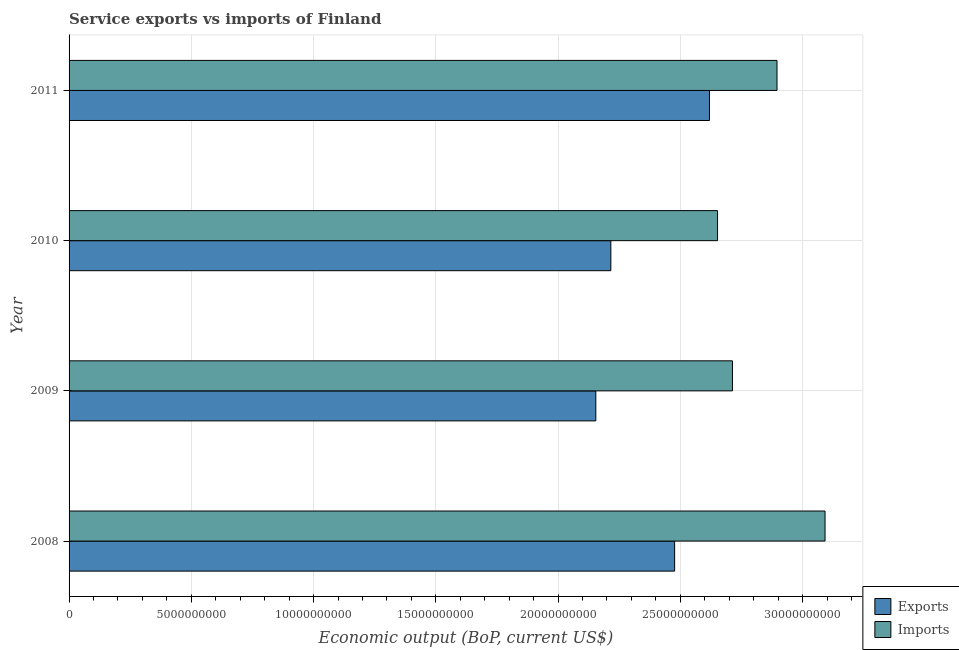How many groups of bars are there?
Offer a very short reply. 4. Are the number of bars on each tick of the Y-axis equal?
Give a very brief answer. Yes. How many bars are there on the 2nd tick from the top?
Make the answer very short. 2. How many bars are there on the 1st tick from the bottom?
Ensure brevity in your answer.  2. What is the amount of service exports in 2008?
Offer a terse response. 2.48e+1. Across all years, what is the maximum amount of service exports?
Keep it short and to the point. 2.62e+1. Across all years, what is the minimum amount of service imports?
Ensure brevity in your answer.  2.65e+1. In which year was the amount of service imports minimum?
Give a very brief answer. 2010. What is the total amount of service exports in the graph?
Offer a terse response. 9.47e+1. What is the difference between the amount of service exports in 2008 and that in 2009?
Give a very brief answer. 3.22e+09. What is the difference between the amount of service exports in 2009 and the amount of service imports in 2010?
Give a very brief answer. -4.98e+09. What is the average amount of service exports per year?
Your answer should be compact. 2.37e+1. In the year 2010, what is the difference between the amount of service imports and amount of service exports?
Provide a succinct answer. 4.36e+09. In how many years, is the amount of service exports greater than 11000000000 US$?
Offer a terse response. 4. Is the amount of service imports in 2008 less than that in 2009?
Your response must be concise. No. Is the difference between the amount of service exports in 2010 and 2011 greater than the difference between the amount of service imports in 2010 and 2011?
Your answer should be very brief. No. What is the difference between the highest and the second highest amount of service exports?
Your answer should be very brief. 1.43e+09. What is the difference between the highest and the lowest amount of service imports?
Give a very brief answer. 4.40e+09. What does the 2nd bar from the top in 2010 represents?
Offer a very short reply. Exports. What does the 1st bar from the bottom in 2008 represents?
Offer a terse response. Exports. How many bars are there?
Keep it short and to the point. 8. How many years are there in the graph?
Your response must be concise. 4. Does the graph contain grids?
Your answer should be very brief. Yes. How many legend labels are there?
Offer a terse response. 2. How are the legend labels stacked?
Keep it short and to the point. Vertical. What is the title of the graph?
Keep it short and to the point. Service exports vs imports of Finland. What is the label or title of the X-axis?
Your answer should be compact. Economic output (BoP, current US$). What is the label or title of the Y-axis?
Offer a very short reply. Year. What is the Economic output (BoP, current US$) in Exports in 2008?
Make the answer very short. 2.48e+1. What is the Economic output (BoP, current US$) in Imports in 2008?
Offer a very short reply. 3.09e+1. What is the Economic output (BoP, current US$) of Exports in 2009?
Offer a terse response. 2.15e+1. What is the Economic output (BoP, current US$) of Imports in 2009?
Provide a succinct answer. 2.71e+1. What is the Economic output (BoP, current US$) of Exports in 2010?
Offer a terse response. 2.22e+1. What is the Economic output (BoP, current US$) of Imports in 2010?
Provide a succinct answer. 2.65e+1. What is the Economic output (BoP, current US$) in Exports in 2011?
Give a very brief answer. 2.62e+1. What is the Economic output (BoP, current US$) in Imports in 2011?
Provide a succinct answer. 2.90e+1. Across all years, what is the maximum Economic output (BoP, current US$) of Exports?
Offer a very short reply. 2.62e+1. Across all years, what is the maximum Economic output (BoP, current US$) in Imports?
Your answer should be compact. 3.09e+1. Across all years, what is the minimum Economic output (BoP, current US$) in Exports?
Make the answer very short. 2.15e+1. Across all years, what is the minimum Economic output (BoP, current US$) in Imports?
Your answer should be compact. 2.65e+1. What is the total Economic output (BoP, current US$) in Exports in the graph?
Your response must be concise. 9.47e+1. What is the total Economic output (BoP, current US$) in Imports in the graph?
Make the answer very short. 1.14e+11. What is the difference between the Economic output (BoP, current US$) in Exports in 2008 and that in 2009?
Provide a succinct answer. 3.22e+09. What is the difference between the Economic output (BoP, current US$) in Imports in 2008 and that in 2009?
Make the answer very short. 3.79e+09. What is the difference between the Economic output (BoP, current US$) in Exports in 2008 and that in 2010?
Your response must be concise. 2.61e+09. What is the difference between the Economic output (BoP, current US$) in Imports in 2008 and that in 2010?
Make the answer very short. 4.40e+09. What is the difference between the Economic output (BoP, current US$) of Exports in 2008 and that in 2011?
Give a very brief answer. -1.43e+09. What is the difference between the Economic output (BoP, current US$) of Imports in 2008 and that in 2011?
Give a very brief answer. 1.96e+09. What is the difference between the Economic output (BoP, current US$) in Exports in 2009 and that in 2010?
Ensure brevity in your answer.  -6.15e+08. What is the difference between the Economic output (BoP, current US$) of Imports in 2009 and that in 2010?
Your answer should be very brief. 6.09e+08. What is the difference between the Economic output (BoP, current US$) of Exports in 2009 and that in 2011?
Your answer should be compact. -4.65e+09. What is the difference between the Economic output (BoP, current US$) of Imports in 2009 and that in 2011?
Make the answer very short. -1.82e+09. What is the difference between the Economic output (BoP, current US$) of Exports in 2010 and that in 2011?
Provide a short and direct response. -4.03e+09. What is the difference between the Economic output (BoP, current US$) of Imports in 2010 and that in 2011?
Offer a terse response. -2.43e+09. What is the difference between the Economic output (BoP, current US$) in Exports in 2008 and the Economic output (BoP, current US$) in Imports in 2009?
Give a very brief answer. -2.36e+09. What is the difference between the Economic output (BoP, current US$) in Exports in 2008 and the Economic output (BoP, current US$) in Imports in 2010?
Keep it short and to the point. -1.76e+09. What is the difference between the Economic output (BoP, current US$) in Exports in 2008 and the Economic output (BoP, current US$) in Imports in 2011?
Give a very brief answer. -4.19e+09. What is the difference between the Economic output (BoP, current US$) in Exports in 2009 and the Economic output (BoP, current US$) in Imports in 2010?
Provide a succinct answer. -4.98e+09. What is the difference between the Economic output (BoP, current US$) of Exports in 2009 and the Economic output (BoP, current US$) of Imports in 2011?
Your answer should be compact. -7.41e+09. What is the difference between the Economic output (BoP, current US$) of Exports in 2010 and the Economic output (BoP, current US$) of Imports in 2011?
Make the answer very short. -6.80e+09. What is the average Economic output (BoP, current US$) of Exports per year?
Offer a very short reply. 2.37e+1. What is the average Economic output (BoP, current US$) of Imports per year?
Keep it short and to the point. 2.84e+1. In the year 2008, what is the difference between the Economic output (BoP, current US$) of Exports and Economic output (BoP, current US$) of Imports?
Your answer should be compact. -6.15e+09. In the year 2009, what is the difference between the Economic output (BoP, current US$) in Exports and Economic output (BoP, current US$) in Imports?
Provide a succinct answer. -5.59e+09. In the year 2010, what is the difference between the Economic output (BoP, current US$) in Exports and Economic output (BoP, current US$) in Imports?
Keep it short and to the point. -4.36e+09. In the year 2011, what is the difference between the Economic output (BoP, current US$) of Exports and Economic output (BoP, current US$) of Imports?
Ensure brevity in your answer.  -2.76e+09. What is the ratio of the Economic output (BoP, current US$) of Exports in 2008 to that in 2009?
Your answer should be very brief. 1.15. What is the ratio of the Economic output (BoP, current US$) in Imports in 2008 to that in 2009?
Provide a succinct answer. 1.14. What is the ratio of the Economic output (BoP, current US$) of Exports in 2008 to that in 2010?
Your response must be concise. 1.12. What is the ratio of the Economic output (BoP, current US$) in Imports in 2008 to that in 2010?
Provide a succinct answer. 1.17. What is the ratio of the Economic output (BoP, current US$) in Exports in 2008 to that in 2011?
Provide a short and direct response. 0.95. What is the ratio of the Economic output (BoP, current US$) of Imports in 2008 to that in 2011?
Your answer should be compact. 1.07. What is the ratio of the Economic output (BoP, current US$) in Exports in 2009 to that in 2010?
Provide a succinct answer. 0.97. What is the ratio of the Economic output (BoP, current US$) in Imports in 2009 to that in 2010?
Ensure brevity in your answer.  1.02. What is the ratio of the Economic output (BoP, current US$) in Exports in 2009 to that in 2011?
Ensure brevity in your answer.  0.82. What is the ratio of the Economic output (BoP, current US$) of Imports in 2009 to that in 2011?
Offer a terse response. 0.94. What is the ratio of the Economic output (BoP, current US$) of Exports in 2010 to that in 2011?
Give a very brief answer. 0.85. What is the ratio of the Economic output (BoP, current US$) of Imports in 2010 to that in 2011?
Provide a short and direct response. 0.92. What is the difference between the highest and the second highest Economic output (BoP, current US$) in Exports?
Offer a very short reply. 1.43e+09. What is the difference between the highest and the second highest Economic output (BoP, current US$) in Imports?
Offer a very short reply. 1.96e+09. What is the difference between the highest and the lowest Economic output (BoP, current US$) of Exports?
Ensure brevity in your answer.  4.65e+09. What is the difference between the highest and the lowest Economic output (BoP, current US$) in Imports?
Ensure brevity in your answer.  4.40e+09. 